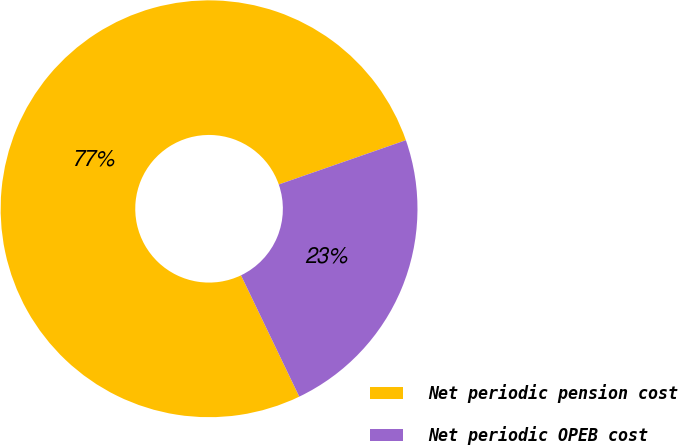Convert chart to OTSL. <chart><loc_0><loc_0><loc_500><loc_500><pie_chart><fcel>Net periodic pension cost<fcel>Net periodic OPEB cost<nl><fcel>76.79%<fcel>23.21%<nl></chart> 